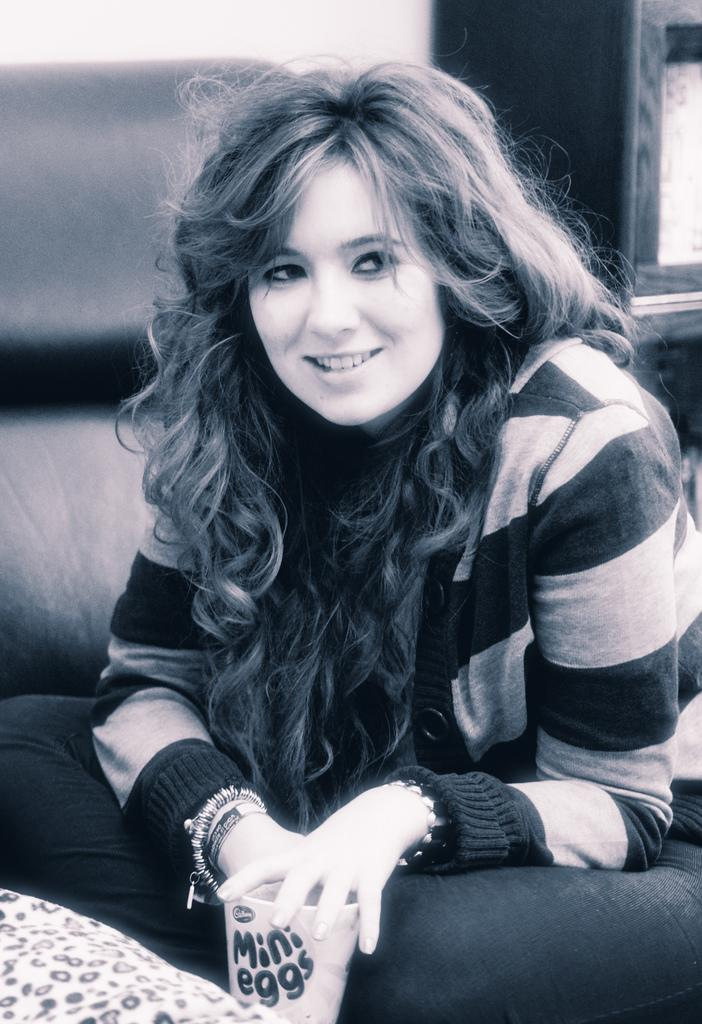What is the person in the image doing? The person is sitting in the image. What expression does the person have? The person is smiling. What is the person holding in the image? There is a cup in the image. What can be seen in the background of the image? There are objects visible in the background. What is the color scheme of the image? The image is in black and white. What type of behavior is the person's sister exhibiting in the image? There is no mention of a sister in the image, so it is not possible to determine the behavior of a sister. 